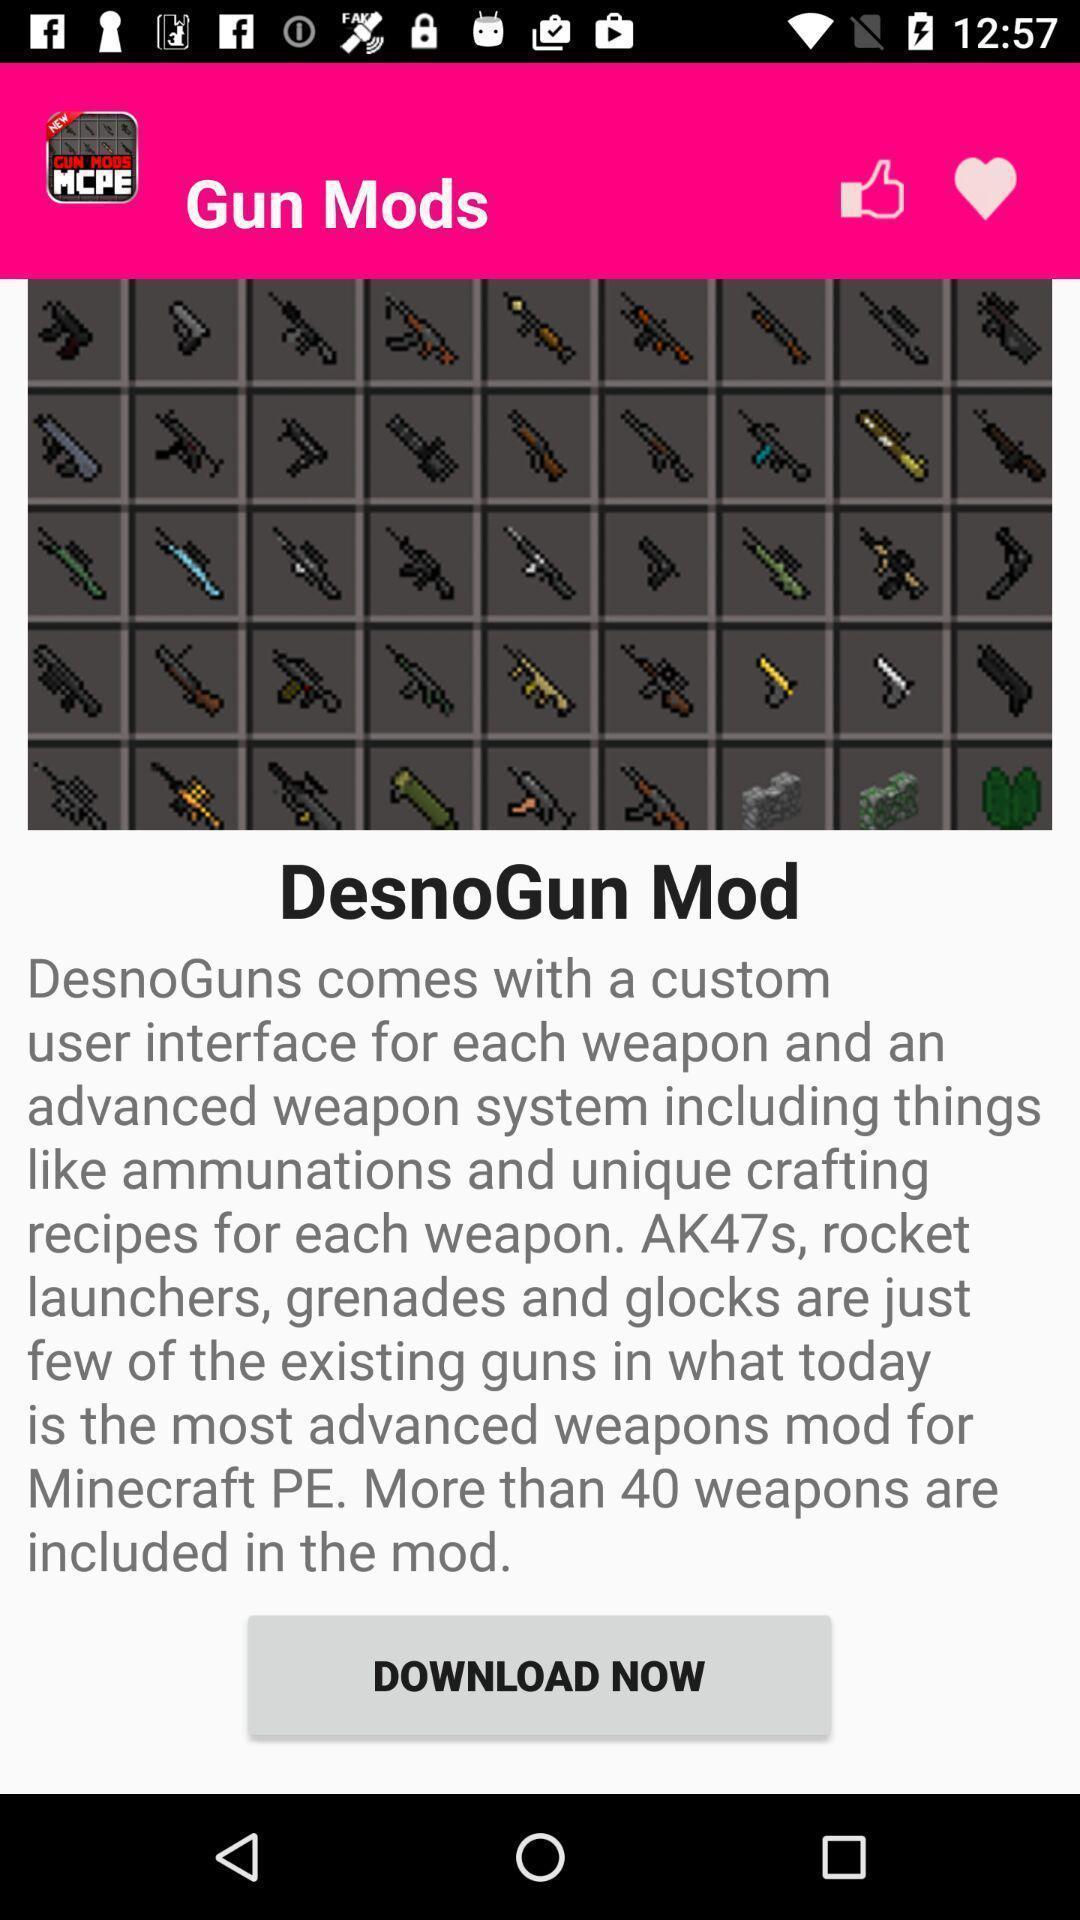Describe this image in words. Screen displaying about to download an app. 